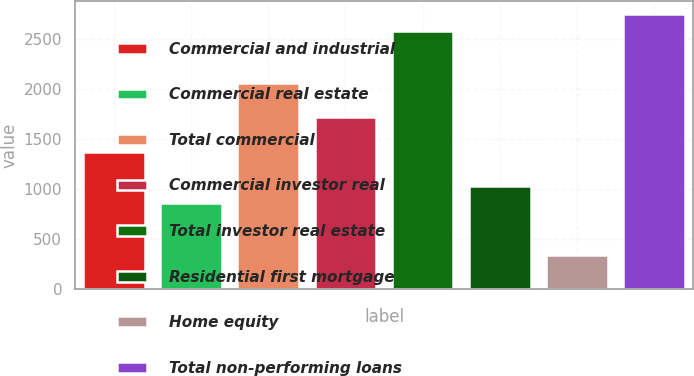Convert chart. <chart><loc_0><loc_0><loc_500><loc_500><bar_chart><fcel>Commercial and industrial<fcel>Commercial real estate<fcel>Total commercial<fcel>Commercial investor real<fcel>Total investor real estate<fcel>Residential first mortgage<fcel>Home equity<fcel>Total non-performing loans<nl><fcel>1374.71<fcel>859.76<fcel>2061.31<fcel>1718.01<fcel>2576.26<fcel>1031.41<fcel>344.81<fcel>2747.91<nl></chart> 